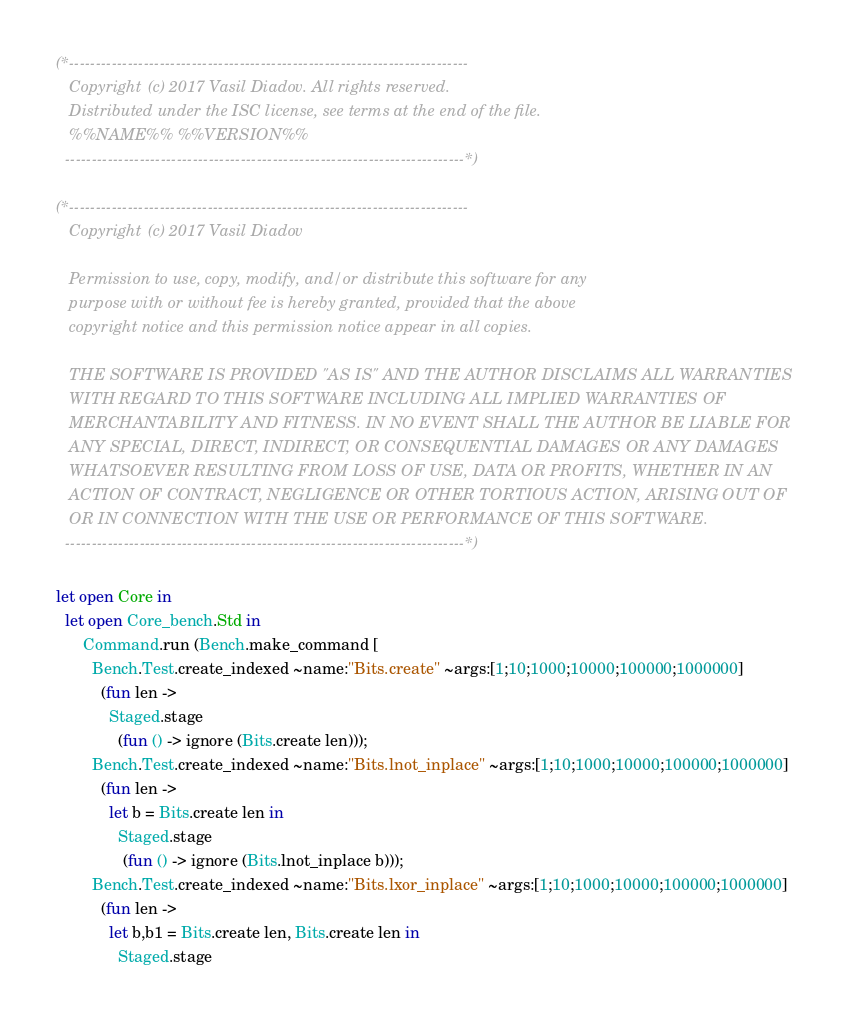Convert code to text. <code><loc_0><loc_0><loc_500><loc_500><_OCaml_>(*---------------------------------------------------------------------------
   Copyright (c) 2017 Vasil Diadov. All rights reserved.
   Distributed under the ISC license, see terms at the end of the file.
   %%NAME%% %%VERSION%%
  ---------------------------------------------------------------------------*)

(*---------------------------------------------------------------------------
   Copyright (c) 2017 Vasil Diadov

   Permission to use, copy, modify, and/or distribute this software for any
   purpose with or without fee is hereby granted, provided that the above
   copyright notice and this permission notice appear in all copies.

   THE SOFTWARE IS PROVIDED "AS IS" AND THE AUTHOR DISCLAIMS ALL WARRANTIES
   WITH REGARD TO THIS SOFTWARE INCLUDING ALL IMPLIED WARRANTIES OF
   MERCHANTABILITY AND FITNESS. IN NO EVENT SHALL THE AUTHOR BE LIABLE FOR
   ANY SPECIAL, DIRECT, INDIRECT, OR CONSEQUENTIAL DAMAGES OR ANY DAMAGES
   WHATSOEVER RESULTING FROM LOSS OF USE, DATA OR PROFITS, WHETHER IN AN
   ACTION OF CONTRACT, NEGLIGENCE OR OTHER TORTIOUS ACTION, ARISING OUT OF
   OR IN CONNECTION WITH THE USE OR PERFORMANCE OF THIS SOFTWARE.
  ---------------------------------------------------------------------------*)

let open Core in
  let open Core_bench.Std in
      Command.run (Bench.make_command [
        Bench.Test.create_indexed ~name:"Bits.create" ~args:[1;10;1000;10000;100000;1000000]
          (fun len ->
            Staged.stage
              (fun () -> ignore (Bits.create len)));
        Bench.Test.create_indexed ~name:"Bits.lnot_inplace" ~args:[1;10;1000;10000;100000;1000000]
          (fun len ->
            let b = Bits.create len in
              Staged.stage
               (fun () -> ignore (Bits.lnot_inplace b)));
        Bench.Test.create_indexed ~name:"Bits.lxor_inplace" ~args:[1;10;1000;10000;100000;1000000]
          (fun len ->
            let b,b1 = Bits.create len, Bits.create len in
              Staged.stage</code> 